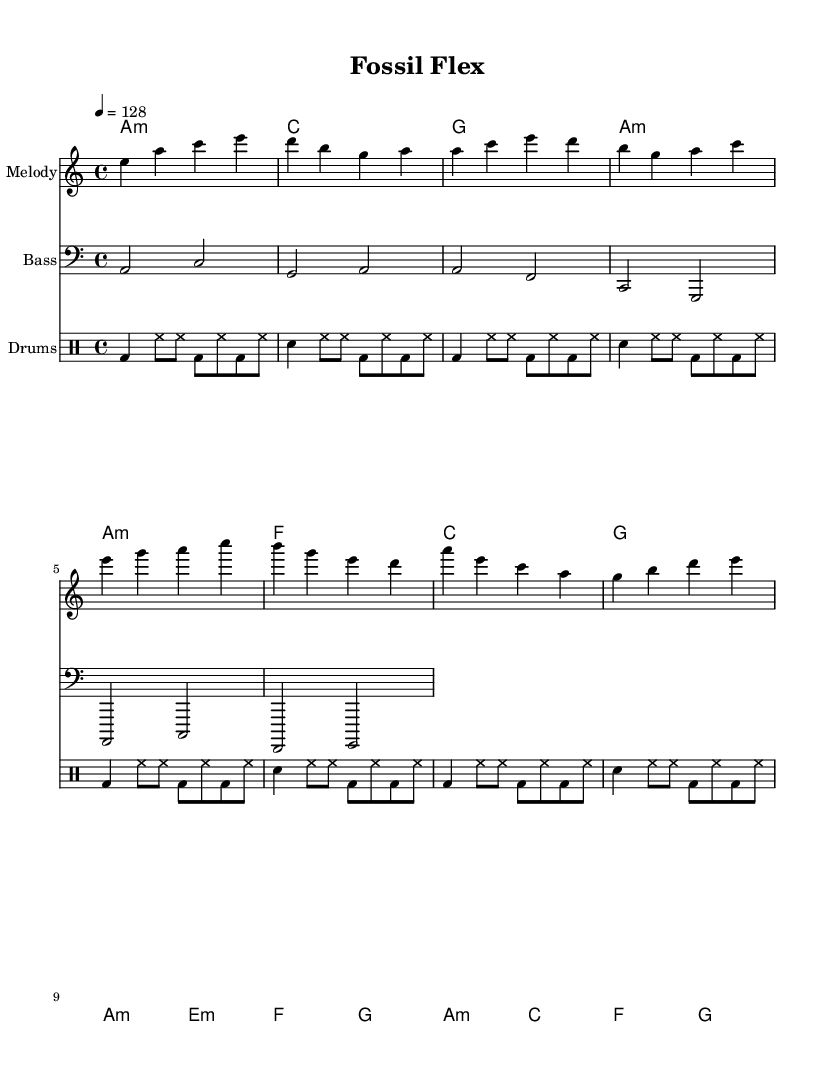What is the key signature of this music? The key signature is noted as A minor, which has no sharps or flats. It can be identified on the left side of the staff at the beginning of the piece.
Answer: A minor What is the time signature of this music? The time signature is indicated at the beginning of the piece as 4/4, meaning there are four beats in each measure, and the quarter note gets one beat. This can also be seen at the start of the sheet music.
Answer: 4/4 What is the tempo marking provided in the music? The tempo marking is set at a tempo of 128 beats per minute, indicated within the text at the start of the score. This informs performers how fast to play the piece.
Answer: 128 What is the instrument name for the melody staff? The instrument name is indicated as "Melody" at the beginning of the corresponding staff. This identifies the specific part meant for the lead vocal or instrumental line.
Answer: Melody How many measures are in the intro section? The intro section consists of two measures as indicated by the two groups of notes following the introductory rhythm. Each group corresponds to one complete measure based on the notation.
Answer: 2 What chord follows the build-up section? The build-up section ends with a chord that leads to the drop, specifically the G chord. This can be deduced from the chord progression listed after the notes of the build-up.
Answer: G What is the texture of the drum part in this piece? The drum part has a texture that repeats simple rhythmic patterns characterized by bass and snare drums, signifying a typical dance music groove. This repetitive style creates an energetic rhythm in the background.
Answer: Repetitive 